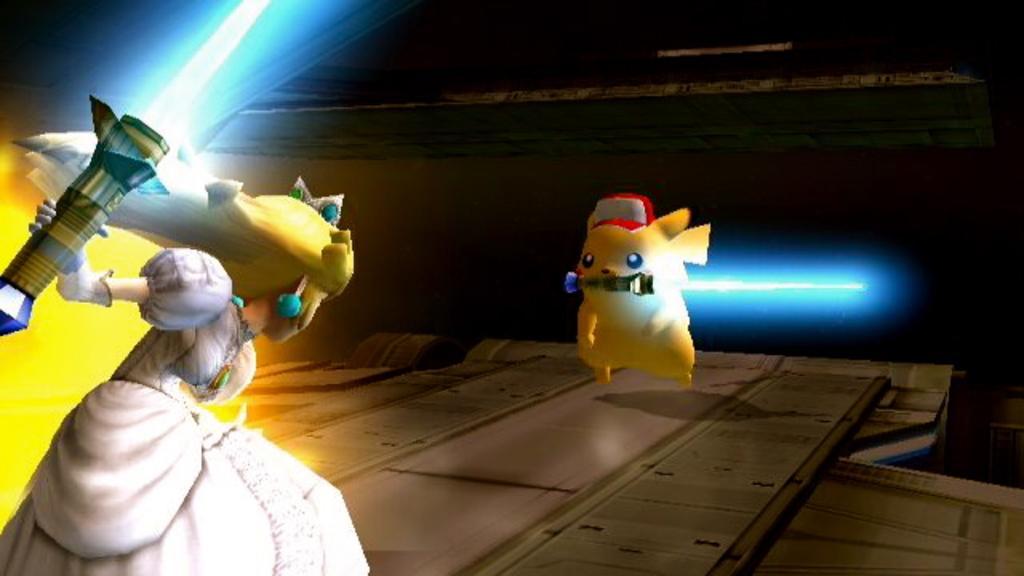Please provide a concise description of this image. In this image we can see an animated picture of an animal, and a lady, there are holding objects, and the background is dark. 